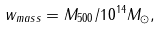Convert formula to latex. <formula><loc_0><loc_0><loc_500><loc_500>w _ { m a s s } = M _ { 5 0 0 } / 1 0 ^ { 1 4 } M _ { \odot } ,</formula> 